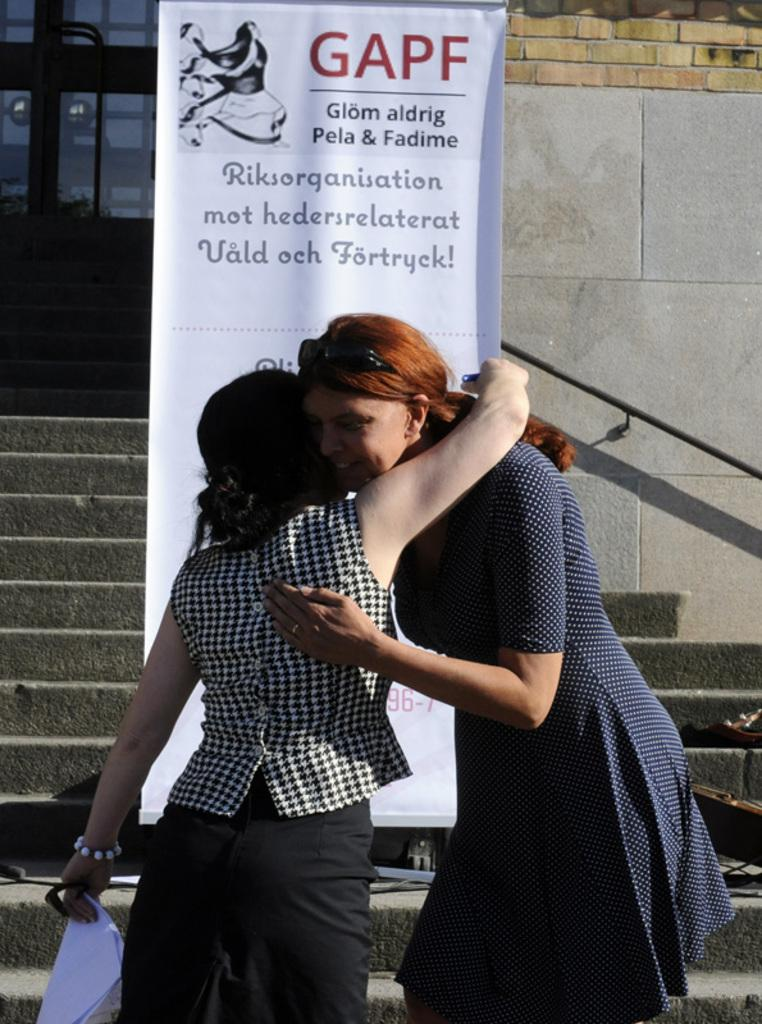How many people are in the image? There are two women in the image. What are the women doing in the image? The women are hugging each other. What position are the women in? The women are standing. What can be seen in the background of the image? There is a banner on a staircase and a wall with a door in the background. What color are the women's toes in the image? There is no information about the women's toes in the image, so we cannot determine their color. 